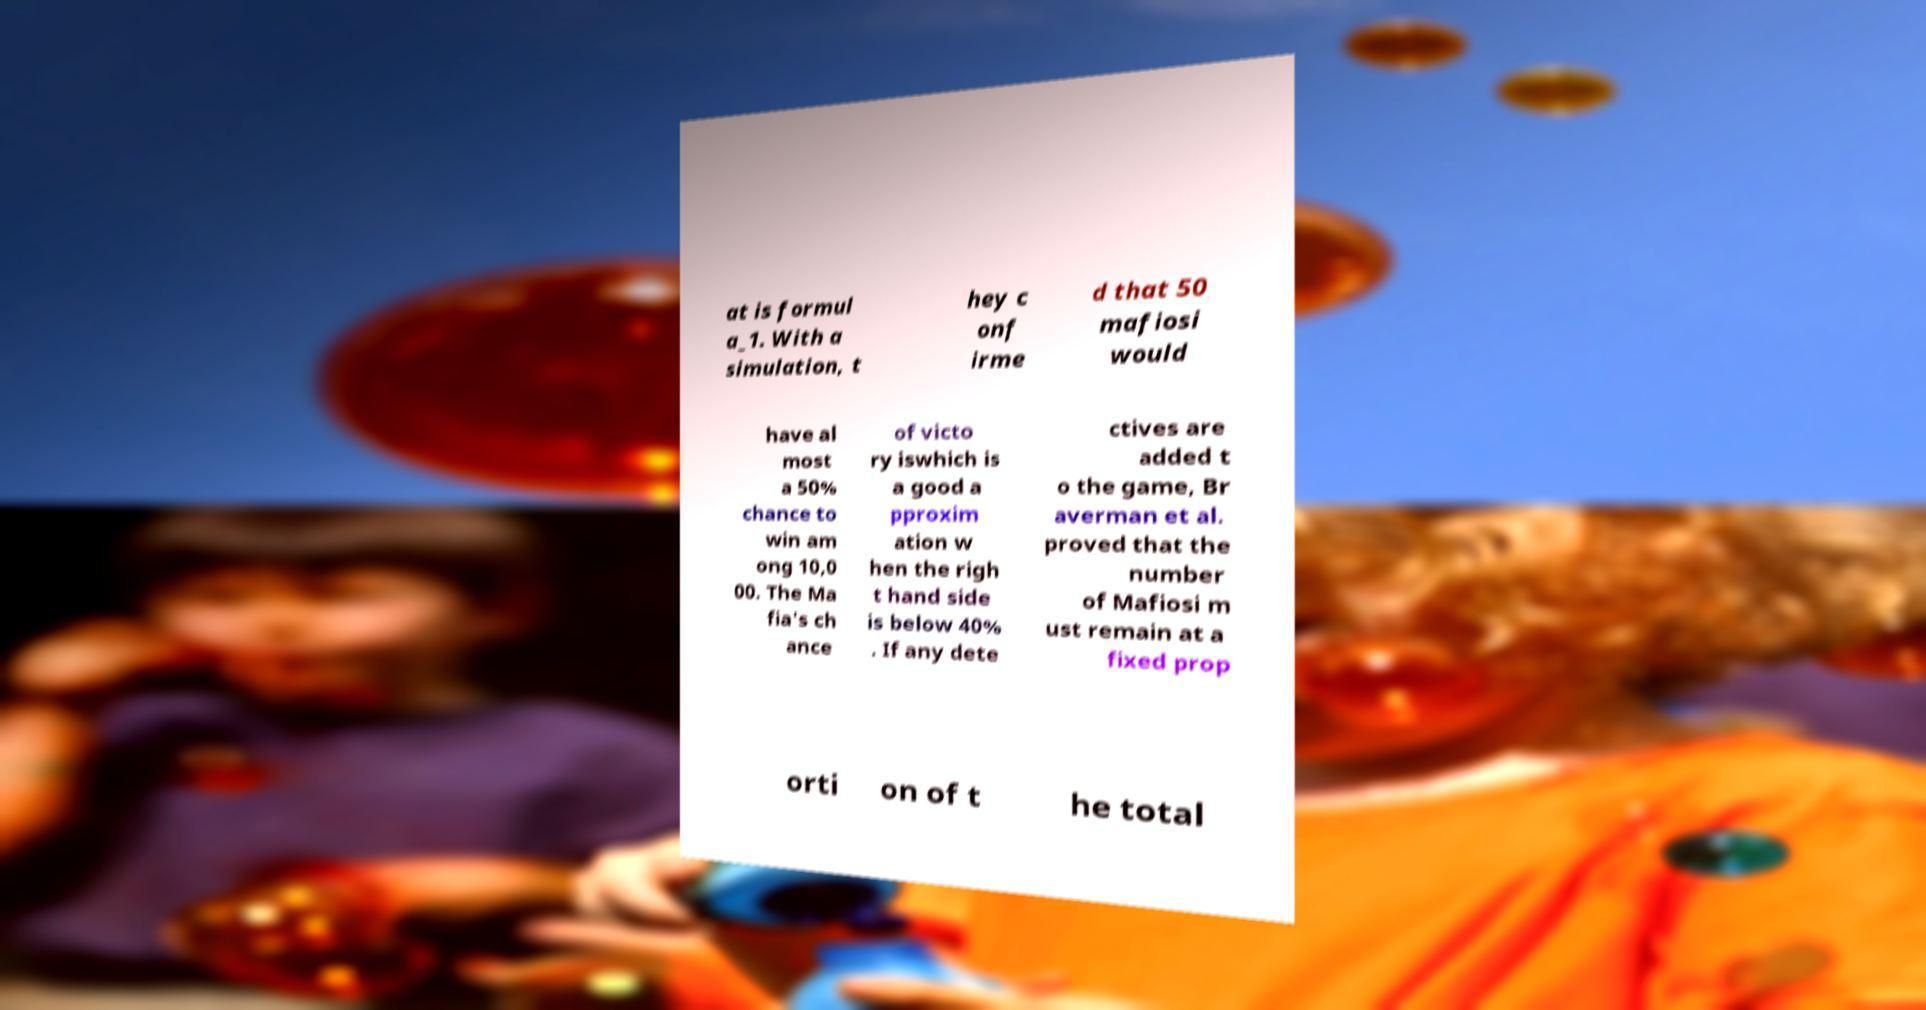I need the written content from this picture converted into text. Can you do that? at is formul a_1. With a simulation, t hey c onf irme d that 50 mafiosi would have al most a 50% chance to win am ong 10,0 00. The Ma fia's ch ance of victo ry iswhich is a good a pproxim ation w hen the righ t hand side is below 40% . If any dete ctives are added t o the game, Br averman et al. proved that the number of Mafiosi m ust remain at a fixed prop orti on of t he total 